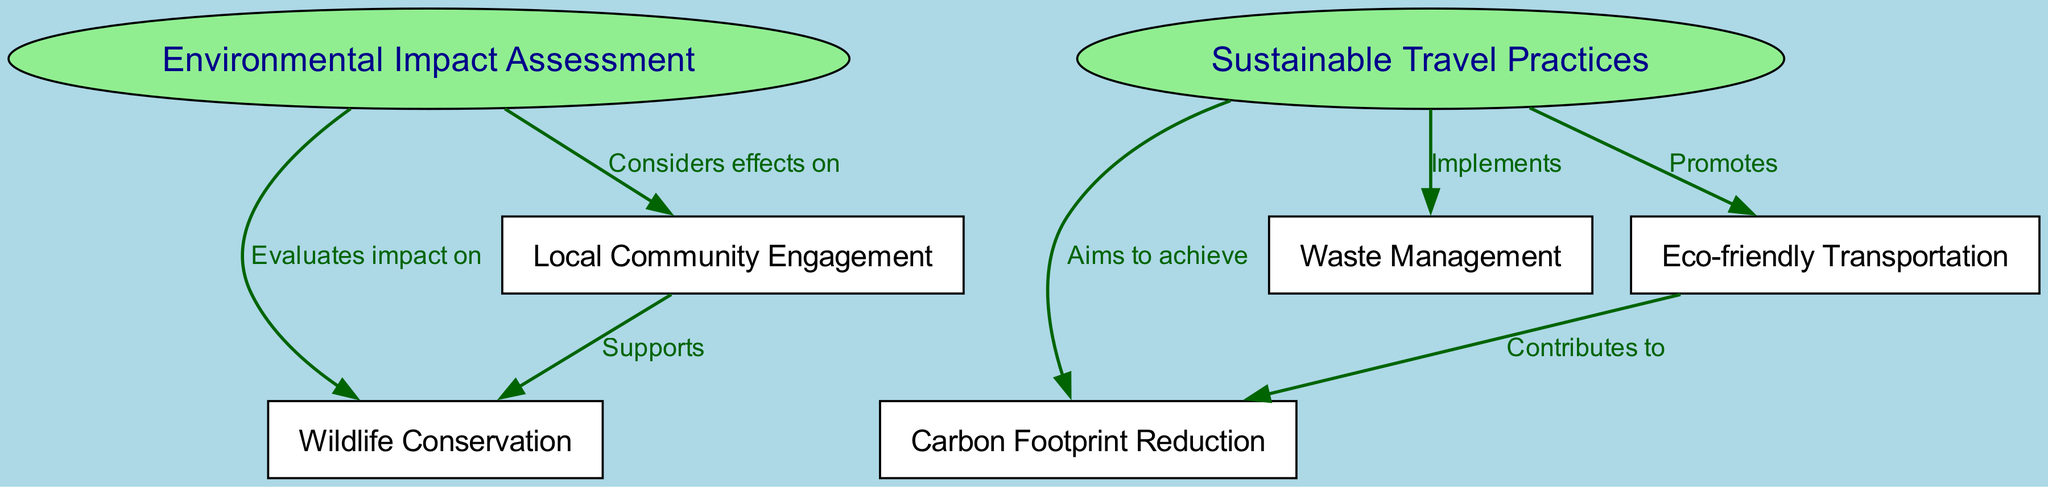What is the main focus of the Environmental Impact Assessment node? The Environmental Impact Assessment node focuses on evaluating the impact on wildlife conservation. This can be identified because there is a directed edge that connects node 1 ("Environmental Impact Assessment") to node 3 ("Wildlife Conservation") with the label "Evaluates impact on".
Answer: Wildlife Conservation How many nodes are present in the diagram? Counting the unique nodes in the diagram, we have a total of 7 nodes: Environmental Impact Assessment, Sustainable Travel Practices, Wildlife Conservation, Carbon Footprint Reduction, Local Community Engagement, Waste Management, and Eco-friendly Transportation.
Answer: 7 Which node is directly associated with Carbon Footprint Reduction? The Carbon Footprint Reduction node is directly associated with Sustainable Travel Practices. This connection is evident since there is an edge from node 2 ("Sustainable Travel Practices") to node 4 ("Carbon Footprint Reduction") labeled "Aims to achieve".
Answer: Sustainable Travel Practices What type of practices does the Sustainable Travel Practices node implement? The Sustainable Travel Practices node implements waste management. This is shown by the edge from node 2 ("Sustainable Travel Practices") to node 6 ("Waste Management") which indicates an implementation relationship.
Answer: Waste Management How does Eco-friendly Transportation contribute to sustainability? Eco-friendly Transportation contributes to carbon footprint reduction. This relationship is shown by the directed edge from node 7 ("Eco-friendly Transportation") to node 4 ("Carbon Footprint Reduction") labeled "Contributes to".
Answer: Carbon Footprint Reduction Which practices support Wildlife Conservation? Local Community Engagement supports wildlife conservation. This is indicated by the edge from node 5 ("Local Community Engagement") to node 3 ("Wildlife Conservation") with the label "Supports".
Answer: Local Community Engagement 